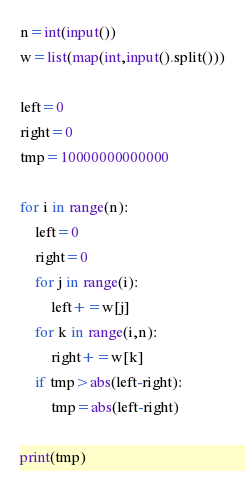<code> <loc_0><loc_0><loc_500><loc_500><_Python_>n=int(input())
w=list(map(int,input().split()))

left=0
right=0
tmp=10000000000000

for i in range(n):
    left=0
    right=0
    for j in range(i):
        left+=w[j]
    for k in range(i,n):
        right+=w[k]
    if tmp>abs(left-right):
        tmp=abs(left-right)

print(tmp)</code> 